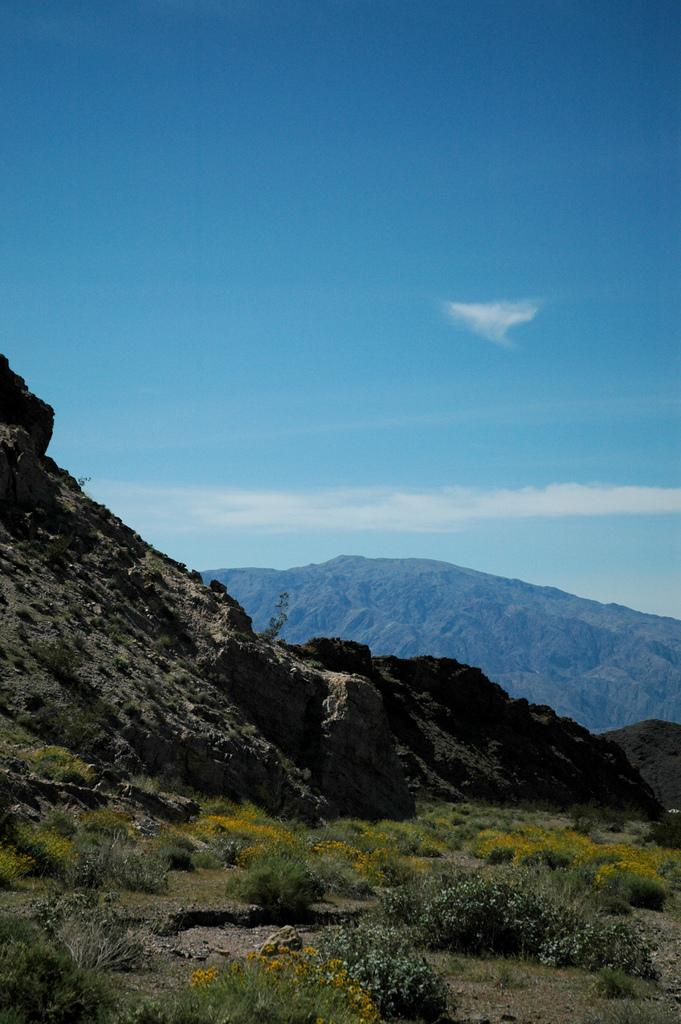What type of vegetation can be seen in the image? There is grass and flowers in the image. How are the flowers arranged in the image? The flowers are grown on plants in the image. What geographical feature is visible in the distance? There are mountains visible in the image. What is the condition of the sky in the image? The sky is clear at the top of the image. What type of hammer is being used to water the plants in the image? There is no hammer present in the image, and plants are not being watered. 